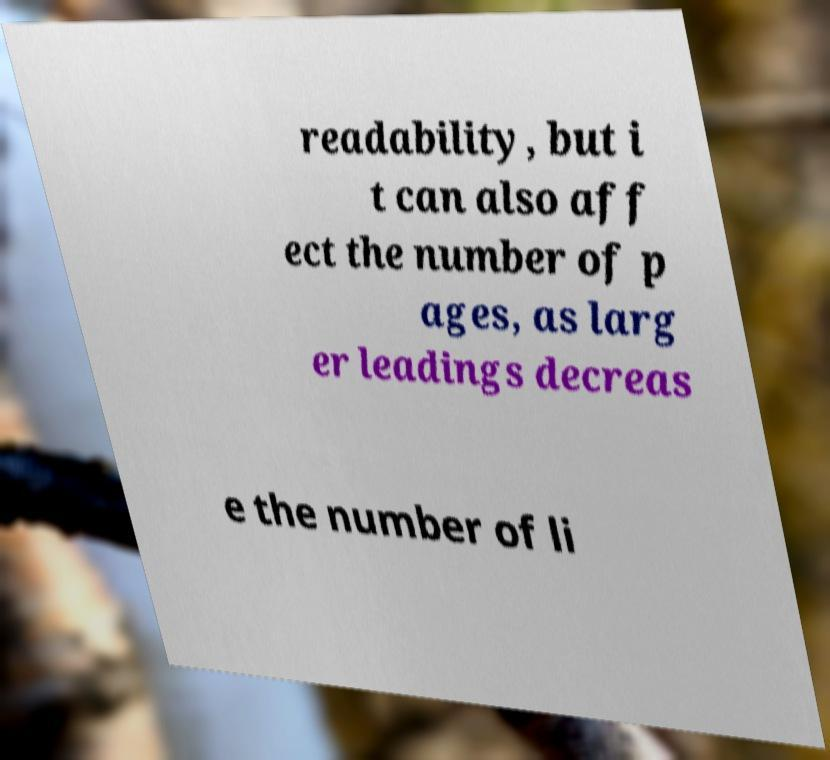Please identify and transcribe the text found in this image. readability, but i t can also aff ect the number of p ages, as larg er leadings decreas e the number of li 